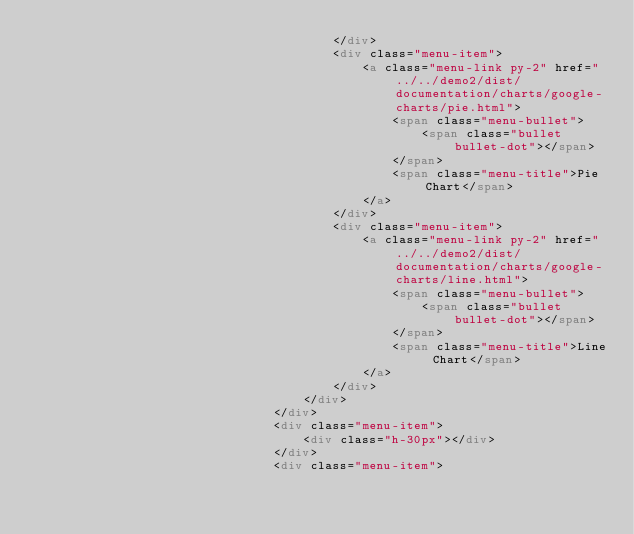<code> <loc_0><loc_0><loc_500><loc_500><_HTML_>										</div>
										<div class="menu-item">
											<a class="menu-link py-2" href="../../demo2/dist/documentation/charts/google-charts/pie.html">
												<span class="menu-bullet">
													<span class="bullet bullet-dot"></span>
												</span>
												<span class="menu-title">Pie Chart</span>
											</a>
										</div>
										<div class="menu-item">
											<a class="menu-link py-2" href="../../demo2/dist/documentation/charts/google-charts/line.html">
												<span class="menu-bullet">
													<span class="bullet bullet-dot"></span>
												</span>
												<span class="menu-title">Line Chart</span>
											</a>
										</div>
									</div>
								</div>
								<div class="menu-item">
									<div class="h-30px"></div>
								</div>
								<div class="menu-item"></code> 